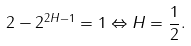<formula> <loc_0><loc_0><loc_500><loc_500>2 - 2 ^ { 2 H - 1 } = 1 \Leftrightarrow H = \frac { 1 } { 2 } .</formula> 